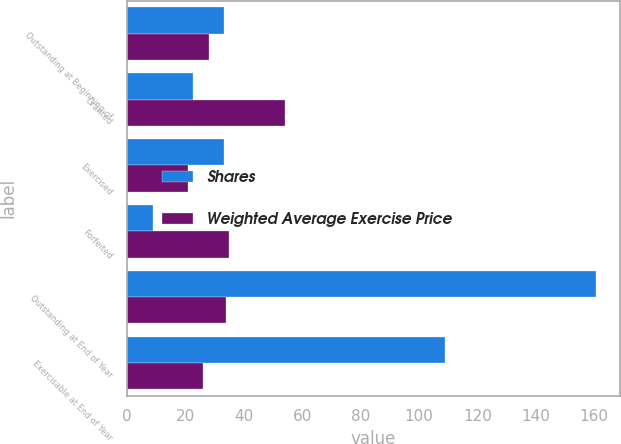<chart> <loc_0><loc_0><loc_500><loc_500><stacked_bar_chart><ecel><fcel>Outstanding at Beginning of<fcel>Granted<fcel>Exercised<fcel>Forfeited<fcel>Outstanding at End of Year<fcel>Exercisable at End of Year<nl><fcel>Shares<fcel>33.1<fcel>22.5<fcel>33.1<fcel>8.9<fcel>160.7<fcel>108.9<nl><fcel>Weighted Average Exercise Price<fcel>28<fcel>54<fcel>21<fcel>35<fcel>34<fcel>26<nl></chart> 